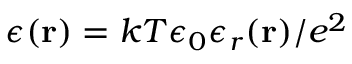Convert formula to latex. <formula><loc_0><loc_0><loc_500><loc_500>\epsilon ( { r } ) = k T \epsilon _ { 0 } \epsilon _ { r } ( { r } ) / e ^ { 2 }</formula> 